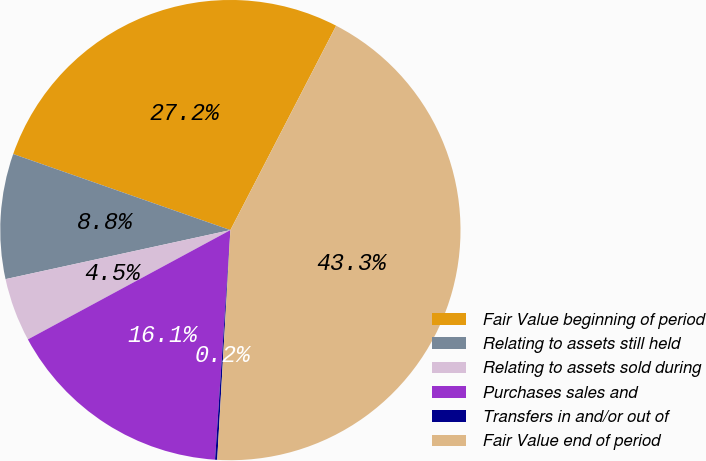Convert chart to OTSL. <chart><loc_0><loc_0><loc_500><loc_500><pie_chart><fcel>Fair Value beginning of period<fcel>Relating to assets still held<fcel>Relating to assets sold during<fcel>Purchases sales and<fcel>Transfers in and/or out of<fcel>Fair Value end of period<nl><fcel>27.24%<fcel>8.78%<fcel>4.46%<fcel>16.06%<fcel>0.15%<fcel>43.31%<nl></chart> 